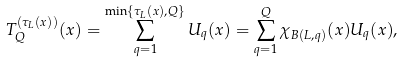<formula> <loc_0><loc_0><loc_500><loc_500>T _ { Q } ^ { ( \tau _ { L } ( x ) ) } ( x ) = \sum _ { q = 1 } ^ { \min \{ \tau _ { L } ( x ) , Q \} } U _ { q } ( x ) = \sum _ { q = 1 } ^ { Q } \chi _ { B ( L , q ) } ( x ) U _ { q } ( x ) ,</formula> 